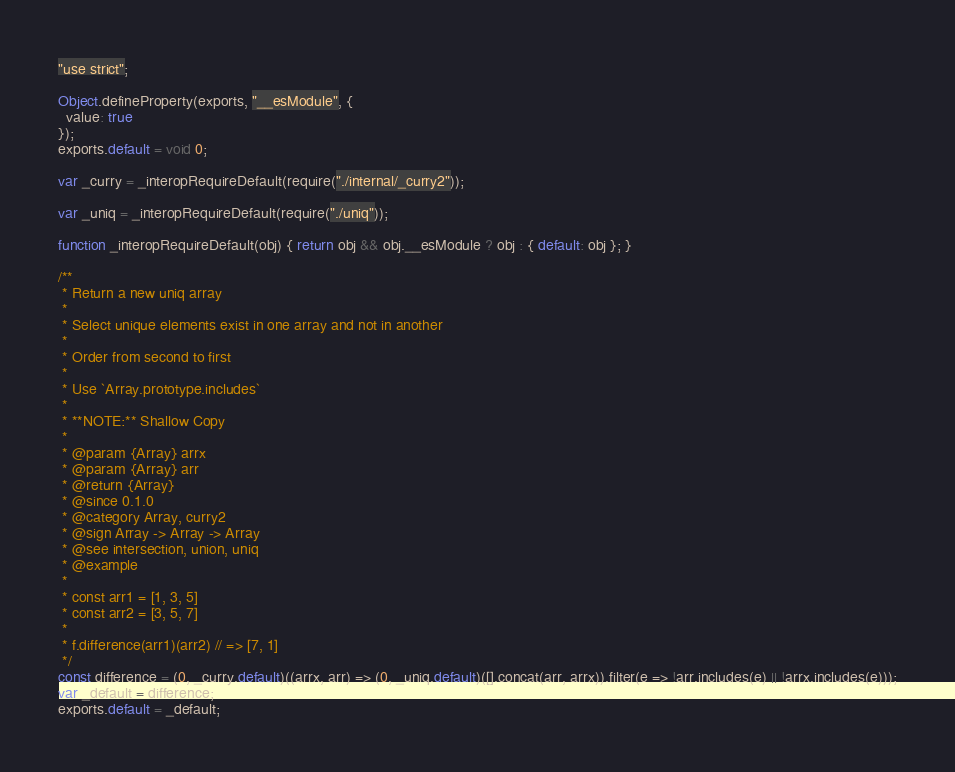Convert code to text. <code><loc_0><loc_0><loc_500><loc_500><_JavaScript_>"use strict";

Object.defineProperty(exports, "__esModule", {
  value: true
});
exports.default = void 0;

var _curry = _interopRequireDefault(require("./internal/_curry2"));

var _uniq = _interopRequireDefault(require("./uniq"));

function _interopRequireDefault(obj) { return obj && obj.__esModule ? obj : { default: obj }; }

/**
 * Return a new uniq array
 * 
 * Select unique elements exist in one array and not in another 
 * 
 * Order from second to first
 * 
 * Use `Array.prototype.includes`
 * 
 * **NOTE:** Shallow Copy
 * 
 * @param {Array} arrx 
 * @param {Array} arr
 * @return {Array}
 * @since 0.1.0
 * @category Array, curry2
 * @sign Array -> Array -> Array
 * @see intersection, union, uniq
 * @example
 * 
 * const arr1 = [1, 3, 5]
 * const arr2 = [3, 5, 7]
 * 
 * f.difference(arr1)(arr2) // => [7, 1]
 */
const difference = (0, _curry.default)((arrx, arr) => (0, _uniq.default)([].concat(arr, arrx)).filter(e => !arr.includes(e) || !arrx.includes(e)));
var _default = difference;
exports.default = _default;</code> 